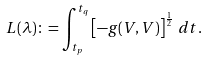Convert formula to latex. <formula><loc_0><loc_0><loc_500><loc_500>L ( \lambda ) \colon = \int _ { t _ { p } } ^ { t _ { q } } \left [ - g ( V , V ) \right ] ^ { \frac { 1 } { 2 } } \, d t .</formula> 